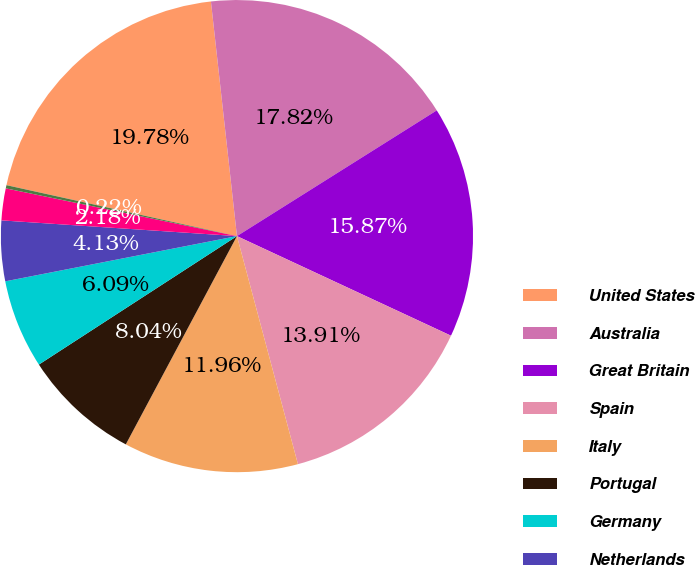Convert chart to OTSL. <chart><loc_0><loc_0><loc_500><loc_500><pie_chart><fcel>United States<fcel>Australia<fcel>Great Britain<fcel>Spain<fcel>Italy<fcel>Portugal<fcel>Germany<fcel>Netherlands<fcel>Belgium<fcel>Greece<nl><fcel>19.78%<fcel>17.82%<fcel>15.87%<fcel>13.91%<fcel>11.96%<fcel>8.04%<fcel>6.09%<fcel>4.13%<fcel>2.18%<fcel>0.22%<nl></chart> 